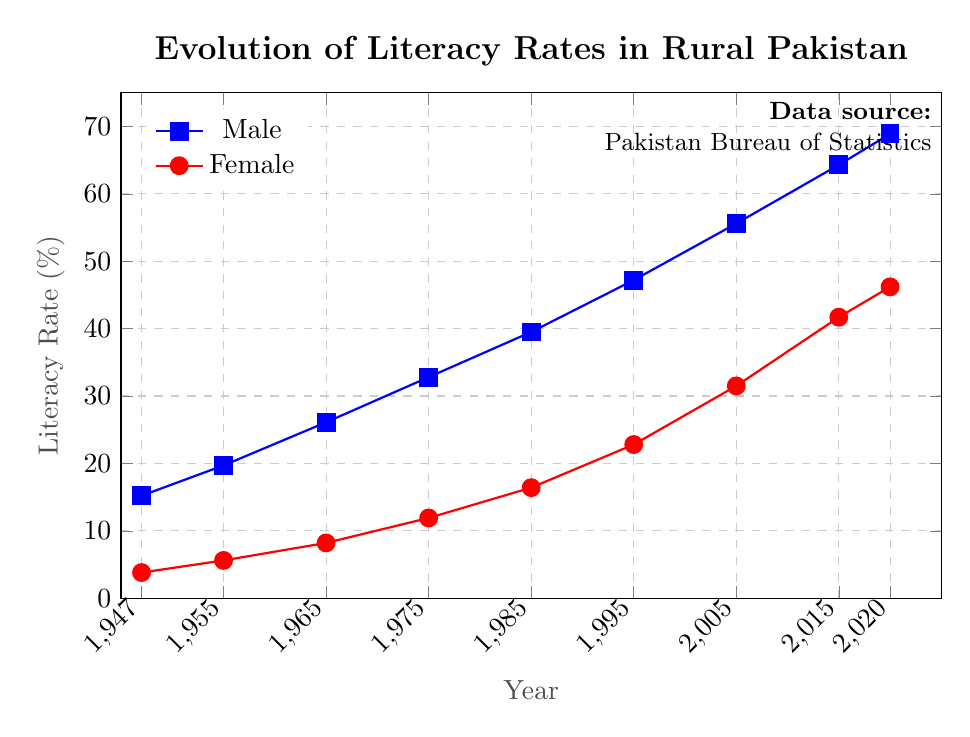What is the literacy rate gap between males and females in 1947? In 1947, the male literacy rate is 15.2% and the female literacy rate is 3.8%. The gap is calculated by subtracting the female rate from the male rate: 15.2 - 3.8 = 11.4
Answer: 11.4% How did the male literacy rate change from 1947 to 2020? The male literacy rate in 1947 was 15.2%, and it increased to 68.9% by 2020. The change is calculated by subtracting the initial rate from the final rate: 68.9 - 15.2 = 53.7
Answer: 53.7% Which year shows the highest increase in male literacy rate compared to the previous decade? Comparing each decade: 1955-1947 (4.5), 1965-1955 (6.4), 1975-1965 (6.7), 1985-1975 (6.7), 1995-1985 (7.7), 2005-1995 (8.4), 2015-2005 (8.7), 2020-2015 (4.6). The highest increase is from 2005 to 2015 with an 8.7% rise
Answer: 2015 What is the average female literacy rate from 1947 to 2020? Sum of female literacy rates is (3.8 + 5.6 + 8.2 + 11.9 + 16.4 + 22.8 + 31.5 + 41.7 + 46.2) = 188.1. There are 9 data points, so the average is 188.1 / 9 ≈ 20.9
Answer: 20.9% Between which decades did the female literacy rate grow the fastest? Comparing each decade: 1955-1947 (1.8), 1965-1955 (2.6), 1975-1965 (3.7), 1985-1975 (4.5), 1995-1985 (6.4), 2005-1995 (8.7), 2015-2005 (10.2), 2020-2015 (4.5). The fastest growth occurred between 2005 and 2015 with a 10.2% increase
Answer: 2005-2015 What visual attribute is used to differentiate between male and female literacy rates? The male literacy rate is represented by a blue line with square markers, while the female literacy rate is represented by a red line with circular markers, differentiating them by color and shape
Answer: Color and shape What is the trend in female literacy rates between 1975 and 1995? In 1975, the female literacy rate is 11.9%. By 1995, it increases to 22.8%. Observing the graph, there is a consistent upward trend between these years.
Answer: Consistent upward trend How much did the female literacy rate increase from 1995 to 2020? The female literacy rate in 1995 was 22.8%, and it increased to 46.2% by 2020. The increase is calculated by subtracting the 1995 rate from the 2020 rate: 46.2 - 22.8 = 23.4
Answer: 23.4% Comparing the initial literacy rates, which gender had a lower rate in 1947? In 1947, the male literacy rate was 15.2% and the female literacy rate was 3.8%. Comparing these rates, females had a lower literacy rate.
Answer: Female Is the increase in male literacy rate between 1985 and 2005 greater or smaller than the increase in female literacy rate in the same period? The male literacy rate increased from 39.5% to 55.6% between 1985 and 2005, an increase of 16.1%. The female literacy rate increased from 16.4% to 31.5%, an increase of 15.1%. Therefore, the increase in the male literacy rate is greater.
Answer: Greater 